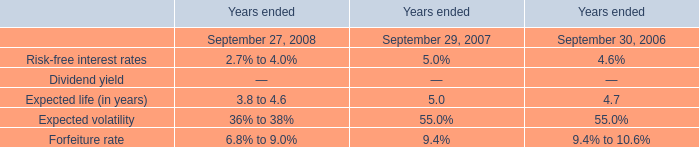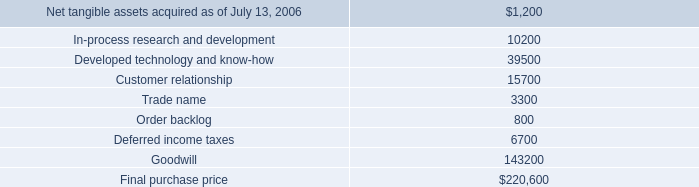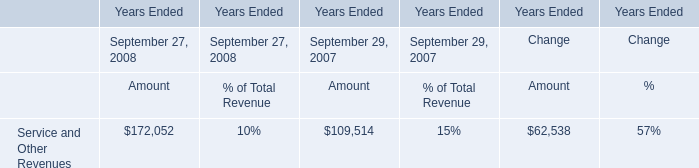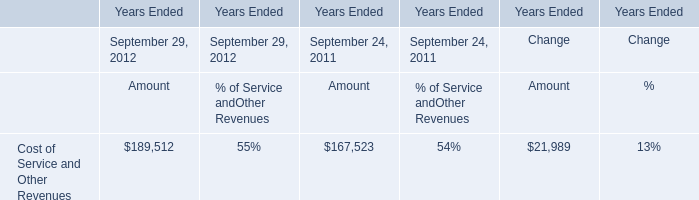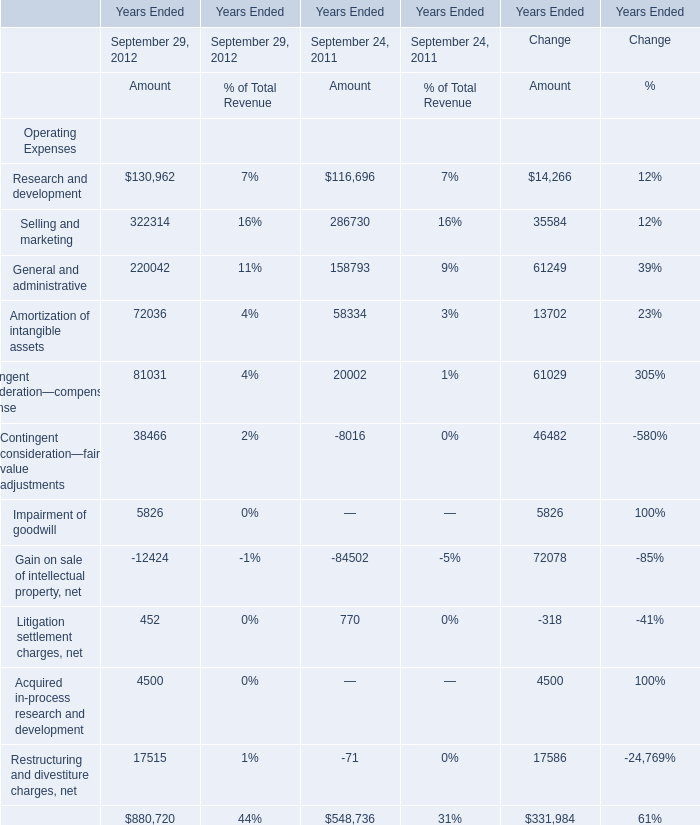what is the estimated price of hologic common stock used in r2 acquisition? 
Computations: (205500 / 8800)
Answer: 23.35227. 